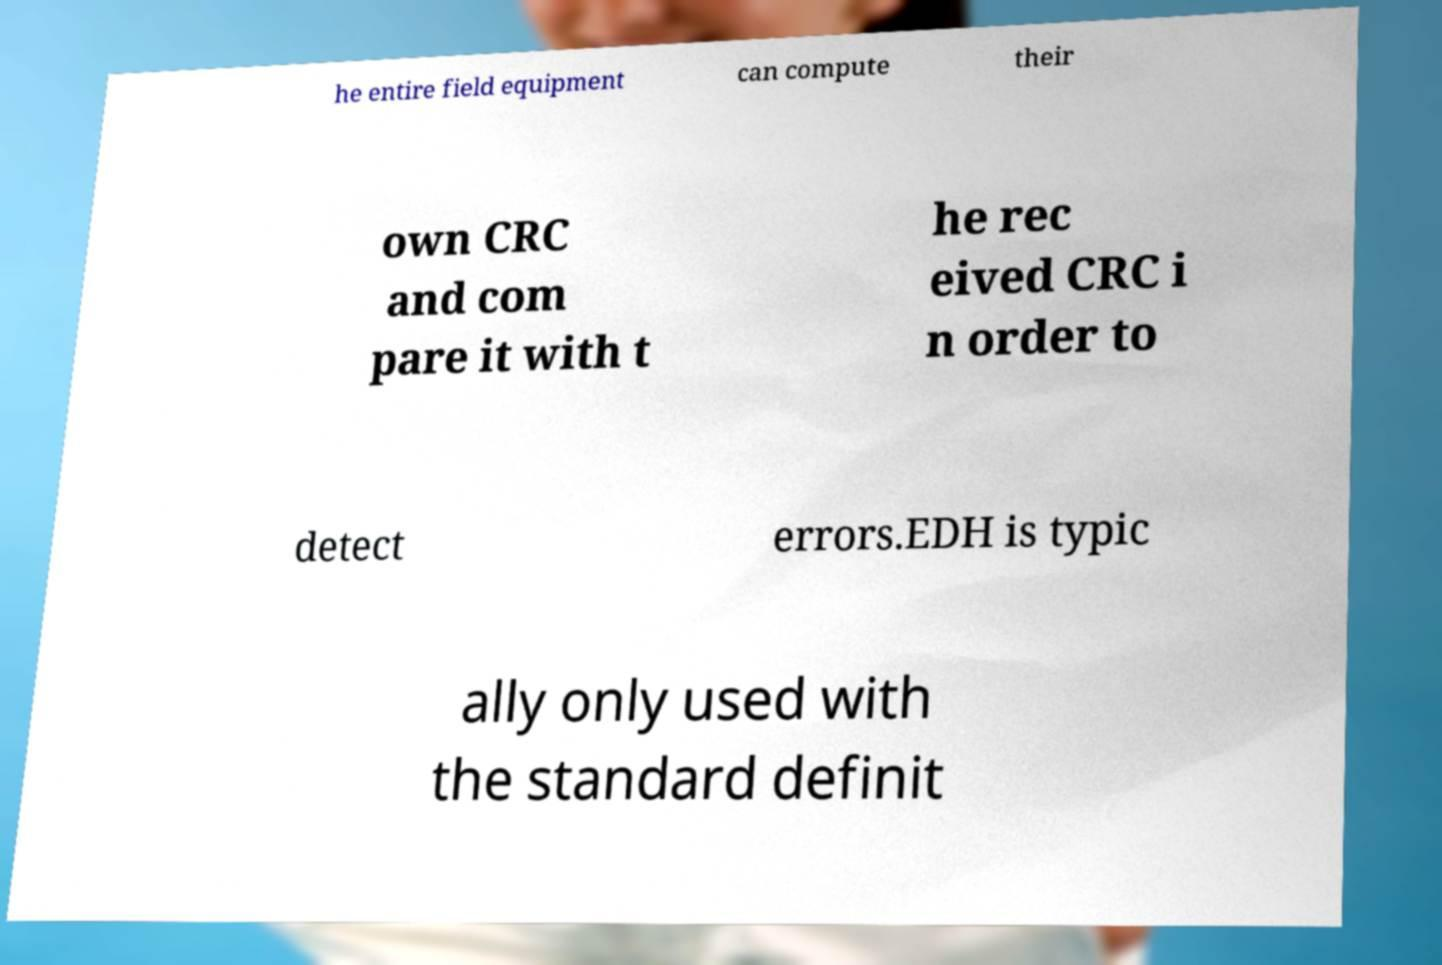I need the written content from this picture converted into text. Can you do that? he entire field equipment can compute their own CRC and com pare it with t he rec eived CRC i n order to detect errors.EDH is typic ally only used with the standard definit 